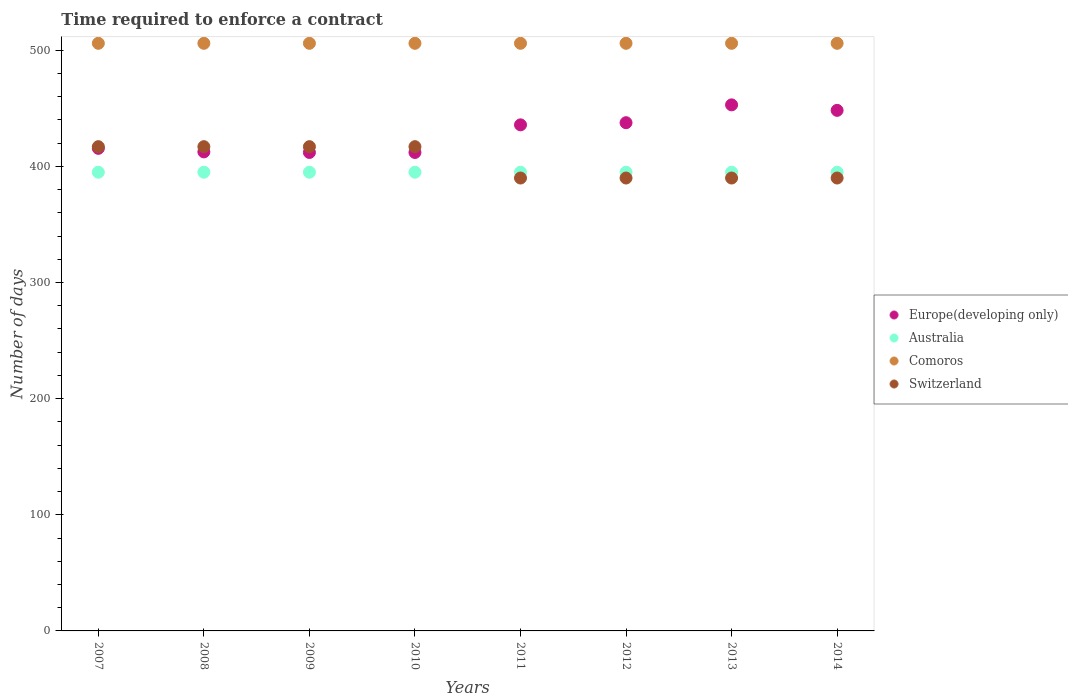How many different coloured dotlines are there?
Provide a short and direct response. 4. What is the number of days required to enforce a contract in Europe(developing only) in 2012?
Ensure brevity in your answer.  437.63. Across all years, what is the maximum number of days required to enforce a contract in Switzerland?
Ensure brevity in your answer.  417. Across all years, what is the minimum number of days required to enforce a contract in Switzerland?
Keep it short and to the point. 390. In which year was the number of days required to enforce a contract in Switzerland maximum?
Provide a succinct answer. 2007. In which year was the number of days required to enforce a contract in Australia minimum?
Offer a very short reply. 2007. What is the total number of days required to enforce a contract in Comoros in the graph?
Keep it short and to the point. 4048. What is the difference between the number of days required to enforce a contract in Australia in 2009 and that in 2011?
Offer a very short reply. 0. What is the difference between the number of days required to enforce a contract in Comoros in 2007 and the number of days required to enforce a contract in Australia in 2012?
Keep it short and to the point. 111. What is the average number of days required to enforce a contract in Europe(developing only) per year?
Keep it short and to the point. 428.34. In the year 2010, what is the difference between the number of days required to enforce a contract in Switzerland and number of days required to enforce a contract in Comoros?
Provide a succinct answer. -89. What is the ratio of the number of days required to enforce a contract in Australia in 2011 to that in 2012?
Provide a short and direct response. 1. Is the number of days required to enforce a contract in Comoros in 2008 less than that in 2010?
Make the answer very short. No. Is the difference between the number of days required to enforce a contract in Switzerland in 2009 and 2014 greater than the difference between the number of days required to enforce a contract in Comoros in 2009 and 2014?
Your answer should be compact. Yes. What is the difference between the highest and the second highest number of days required to enforce a contract in Comoros?
Your answer should be very brief. 0. What is the difference between the highest and the lowest number of days required to enforce a contract in Switzerland?
Provide a succinct answer. 27. In how many years, is the number of days required to enforce a contract in Comoros greater than the average number of days required to enforce a contract in Comoros taken over all years?
Provide a short and direct response. 0. Is the sum of the number of days required to enforce a contract in Switzerland in 2013 and 2014 greater than the maximum number of days required to enforce a contract in Australia across all years?
Offer a very short reply. Yes. Is it the case that in every year, the sum of the number of days required to enforce a contract in Europe(developing only) and number of days required to enforce a contract in Comoros  is greater than the number of days required to enforce a contract in Australia?
Ensure brevity in your answer.  Yes. How many dotlines are there?
Provide a succinct answer. 4. How many years are there in the graph?
Your answer should be compact. 8. Are the values on the major ticks of Y-axis written in scientific E-notation?
Provide a succinct answer. No. Does the graph contain any zero values?
Offer a terse response. No. Does the graph contain grids?
Ensure brevity in your answer.  No. How many legend labels are there?
Your answer should be very brief. 4. What is the title of the graph?
Your answer should be compact. Time required to enforce a contract. Does "Caribbean small states" appear as one of the legend labels in the graph?
Your answer should be compact. No. What is the label or title of the X-axis?
Provide a succinct answer. Years. What is the label or title of the Y-axis?
Your answer should be very brief. Number of days. What is the Number of days of Europe(developing only) in 2007?
Keep it short and to the point. 415.56. What is the Number of days in Australia in 2007?
Give a very brief answer. 395. What is the Number of days of Comoros in 2007?
Offer a terse response. 506. What is the Number of days in Switzerland in 2007?
Provide a short and direct response. 417. What is the Number of days in Europe(developing only) in 2008?
Your answer should be very brief. 412.5. What is the Number of days of Australia in 2008?
Provide a succinct answer. 395. What is the Number of days in Comoros in 2008?
Your answer should be compact. 506. What is the Number of days in Switzerland in 2008?
Offer a terse response. 417. What is the Number of days in Europe(developing only) in 2009?
Provide a short and direct response. 412. What is the Number of days in Australia in 2009?
Provide a short and direct response. 395. What is the Number of days of Comoros in 2009?
Your response must be concise. 506. What is the Number of days in Switzerland in 2009?
Keep it short and to the point. 417. What is the Number of days of Europe(developing only) in 2010?
Keep it short and to the point. 412. What is the Number of days in Australia in 2010?
Keep it short and to the point. 395. What is the Number of days in Comoros in 2010?
Your response must be concise. 506. What is the Number of days in Switzerland in 2010?
Your response must be concise. 417. What is the Number of days in Europe(developing only) in 2011?
Your response must be concise. 435.79. What is the Number of days in Australia in 2011?
Give a very brief answer. 395. What is the Number of days in Comoros in 2011?
Keep it short and to the point. 506. What is the Number of days of Switzerland in 2011?
Your answer should be compact. 390. What is the Number of days in Europe(developing only) in 2012?
Offer a terse response. 437.63. What is the Number of days of Australia in 2012?
Provide a succinct answer. 395. What is the Number of days of Comoros in 2012?
Make the answer very short. 506. What is the Number of days of Switzerland in 2012?
Provide a short and direct response. 390. What is the Number of days in Europe(developing only) in 2013?
Provide a short and direct response. 453. What is the Number of days in Australia in 2013?
Offer a terse response. 395. What is the Number of days of Comoros in 2013?
Provide a short and direct response. 506. What is the Number of days of Switzerland in 2013?
Your answer should be compact. 390. What is the Number of days in Europe(developing only) in 2014?
Keep it short and to the point. 448.26. What is the Number of days of Australia in 2014?
Give a very brief answer. 395. What is the Number of days in Comoros in 2014?
Ensure brevity in your answer.  506. What is the Number of days of Switzerland in 2014?
Make the answer very short. 390. Across all years, what is the maximum Number of days in Europe(developing only)?
Provide a succinct answer. 453. Across all years, what is the maximum Number of days of Australia?
Ensure brevity in your answer.  395. Across all years, what is the maximum Number of days in Comoros?
Your answer should be compact. 506. Across all years, what is the maximum Number of days of Switzerland?
Offer a very short reply. 417. Across all years, what is the minimum Number of days of Europe(developing only)?
Offer a terse response. 412. Across all years, what is the minimum Number of days of Australia?
Keep it short and to the point. 395. Across all years, what is the minimum Number of days in Comoros?
Your answer should be very brief. 506. Across all years, what is the minimum Number of days in Switzerland?
Make the answer very short. 390. What is the total Number of days in Europe(developing only) in the graph?
Your response must be concise. 3426.74. What is the total Number of days in Australia in the graph?
Your response must be concise. 3160. What is the total Number of days of Comoros in the graph?
Ensure brevity in your answer.  4048. What is the total Number of days of Switzerland in the graph?
Your answer should be compact. 3228. What is the difference between the Number of days in Europe(developing only) in 2007 and that in 2008?
Offer a very short reply. 3.06. What is the difference between the Number of days in Australia in 2007 and that in 2008?
Keep it short and to the point. 0. What is the difference between the Number of days in Comoros in 2007 and that in 2008?
Make the answer very short. 0. What is the difference between the Number of days in Switzerland in 2007 and that in 2008?
Your answer should be very brief. 0. What is the difference between the Number of days of Europe(developing only) in 2007 and that in 2009?
Keep it short and to the point. 3.56. What is the difference between the Number of days of Australia in 2007 and that in 2009?
Your answer should be compact. 0. What is the difference between the Number of days of Europe(developing only) in 2007 and that in 2010?
Your response must be concise. 3.56. What is the difference between the Number of days of Europe(developing only) in 2007 and that in 2011?
Provide a short and direct response. -20.23. What is the difference between the Number of days of Comoros in 2007 and that in 2011?
Give a very brief answer. 0. What is the difference between the Number of days of Europe(developing only) in 2007 and that in 2012?
Provide a short and direct response. -22.08. What is the difference between the Number of days in Comoros in 2007 and that in 2012?
Make the answer very short. 0. What is the difference between the Number of days of Europe(developing only) in 2007 and that in 2013?
Ensure brevity in your answer.  -37.44. What is the difference between the Number of days in Europe(developing only) in 2007 and that in 2014?
Your answer should be compact. -32.71. What is the difference between the Number of days in Comoros in 2007 and that in 2014?
Your response must be concise. 0. What is the difference between the Number of days in Switzerland in 2007 and that in 2014?
Offer a terse response. 27. What is the difference between the Number of days in Europe(developing only) in 2008 and that in 2009?
Your answer should be very brief. 0.5. What is the difference between the Number of days of Comoros in 2008 and that in 2009?
Provide a short and direct response. 0. What is the difference between the Number of days in Comoros in 2008 and that in 2010?
Give a very brief answer. 0. What is the difference between the Number of days of Switzerland in 2008 and that in 2010?
Your answer should be compact. 0. What is the difference between the Number of days of Europe(developing only) in 2008 and that in 2011?
Ensure brevity in your answer.  -23.29. What is the difference between the Number of days of Switzerland in 2008 and that in 2011?
Make the answer very short. 27. What is the difference between the Number of days in Europe(developing only) in 2008 and that in 2012?
Offer a very short reply. -25.13. What is the difference between the Number of days of Switzerland in 2008 and that in 2012?
Your answer should be very brief. 27. What is the difference between the Number of days of Europe(developing only) in 2008 and that in 2013?
Ensure brevity in your answer.  -40.5. What is the difference between the Number of days of Australia in 2008 and that in 2013?
Your answer should be compact. 0. What is the difference between the Number of days of Switzerland in 2008 and that in 2013?
Ensure brevity in your answer.  27. What is the difference between the Number of days in Europe(developing only) in 2008 and that in 2014?
Keep it short and to the point. -35.76. What is the difference between the Number of days in Australia in 2008 and that in 2014?
Give a very brief answer. 0. What is the difference between the Number of days in Comoros in 2008 and that in 2014?
Provide a succinct answer. 0. What is the difference between the Number of days in Comoros in 2009 and that in 2010?
Offer a terse response. 0. What is the difference between the Number of days of Switzerland in 2009 and that in 2010?
Your answer should be very brief. 0. What is the difference between the Number of days in Europe(developing only) in 2009 and that in 2011?
Provide a short and direct response. -23.79. What is the difference between the Number of days of Australia in 2009 and that in 2011?
Make the answer very short. 0. What is the difference between the Number of days in Comoros in 2009 and that in 2011?
Provide a short and direct response. 0. What is the difference between the Number of days of Switzerland in 2009 and that in 2011?
Offer a very short reply. 27. What is the difference between the Number of days of Europe(developing only) in 2009 and that in 2012?
Offer a very short reply. -25.63. What is the difference between the Number of days in Australia in 2009 and that in 2012?
Offer a very short reply. 0. What is the difference between the Number of days of Comoros in 2009 and that in 2012?
Give a very brief answer. 0. What is the difference between the Number of days of Switzerland in 2009 and that in 2012?
Ensure brevity in your answer.  27. What is the difference between the Number of days of Europe(developing only) in 2009 and that in 2013?
Offer a terse response. -41. What is the difference between the Number of days in Switzerland in 2009 and that in 2013?
Ensure brevity in your answer.  27. What is the difference between the Number of days in Europe(developing only) in 2009 and that in 2014?
Make the answer very short. -36.26. What is the difference between the Number of days in Comoros in 2009 and that in 2014?
Your answer should be compact. 0. What is the difference between the Number of days of Switzerland in 2009 and that in 2014?
Ensure brevity in your answer.  27. What is the difference between the Number of days of Europe(developing only) in 2010 and that in 2011?
Provide a short and direct response. -23.79. What is the difference between the Number of days in Australia in 2010 and that in 2011?
Make the answer very short. 0. What is the difference between the Number of days of Comoros in 2010 and that in 2011?
Your response must be concise. 0. What is the difference between the Number of days in Europe(developing only) in 2010 and that in 2012?
Offer a terse response. -25.63. What is the difference between the Number of days of Comoros in 2010 and that in 2012?
Offer a terse response. 0. What is the difference between the Number of days in Switzerland in 2010 and that in 2012?
Give a very brief answer. 27. What is the difference between the Number of days of Europe(developing only) in 2010 and that in 2013?
Keep it short and to the point. -41. What is the difference between the Number of days of Australia in 2010 and that in 2013?
Provide a short and direct response. 0. What is the difference between the Number of days in Switzerland in 2010 and that in 2013?
Your answer should be very brief. 27. What is the difference between the Number of days in Europe(developing only) in 2010 and that in 2014?
Make the answer very short. -36.26. What is the difference between the Number of days of Europe(developing only) in 2011 and that in 2012?
Provide a succinct answer. -1.84. What is the difference between the Number of days in Europe(developing only) in 2011 and that in 2013?
Provide a succinct answer. -17.21. What is the difference between the Number of days of Australia in 2011 and that in 2013?
Provide a short and direct response. 0. What is the difference between the Number of days in Comoros in 2011 and that in 2013?
Offer a very short reply. 0. What is the difference between the Number of days of Europe(developing only) in 2011 and that in 2014?
Your response must be concise. -12.47. What is the difference between the Number of days in Comoros in 2011 and that in 2014?
Keep it short and to the point. 0. What is the difference between the Number of days in Europe(developing only) in 2012 and that in 2013?
Give a very brief answer. -15.37. What is the difference between the Number of days in Comoros in 2012 and that in 2013?
Offer a very short reply. 0. What is the difference between the Number of days in Switzerland in 2012 and that in 2013?
Offer a terse response. 0. What is the difference between the Number of days of Europe(developing only) in 2012 and that in 2014?
Your response must be concise. -10.63. What is the difference between the Number of days in Comoros in 2012 and that in 2014?
Provide a succinct answer. 0. What is the difference between the Number of days in Europe(developing only) in 2013 and that in 2014?
Your answer should be compact. 4.74. What is the difference between the Number of days in Australia in 2013 and that in 2014?
Your answer should be very brief. 0. What is the difference between the Number of days in Europe(developing only) in 2007 and the Number of days in Australia in 2008?
Your answer should be compact. 20.56. What is the difference between the Number of days in Europe(developing only) in 2007 and the Number of days in Comoros in 2008?
Offer a very short reply. -90.44. What is the difference between the Number of days in Europe(developing only) in 2007 and the Number of days in Switzerland in 2008?
Ensure brevity in your answer.  -1.44. What is the difference between the Number of days of Australia in 2007 and the Number of days of Comoros in 2008?
Make the answer very short. -111. What is the difference between the Number of days in Australia in 2007 and the Number of days in Switzerland in 2008?
Your answer should be very brief. -22. What is the difference between the Number of days in Comoros in 2007 and the Number of days in Switzerland in 2008?
Make the answer very short. 89. What is the difference between the Number of days in Europe(developing only) in 2007 and the Number of days in Australia in 2009?
Your answer should be compact. 20.56. What is the difference between the Number of days in Europe(developing only) in 2007 and the Number of days in Comoros in 2009?
Offer a terse response. -90.44. What is the difference between the Number of days in Europe(developing only) in 2007 and the Number of days in Switzerland in 2009?
Your answer should be very brief. -1.44. What is the difference between the Number of days of Australia in 2007 and the Number of days of Comoros in 2009?
Keep it short and to the point. -111. What is the difference between the Number of days in Comoros in 2007 and the Number of days in Switzerland in 2009?
Ensure brevity in your answer.  89. What is the difference between the Number of days in Europe(developing only) in 2007 and the Number of days in Australia in 2010?
Provide a short and direct response. 20.56. What is the difference between the Number of days in Europe(developing only) in 2007 and the Number of days in Comoros in 2010?
Provide a succinct answer. -90.44. What is the difference between the Number of days in Europe(developing only) in 2007 and the Number of days in Switzerland in 2010?
Provide a succinct answer. -1.44. What is the difference between the Number of days of Australia in 2007 and the Number of days of Comoros in 2010?
Provide a short and direct response. -111. What is the difference between the Number of days of Australia in 2007 and the Number of days of Switzerland in 2010?
Ensure brevity in your answer.  -22. What is the difference between the Number of days of Comoros in 2007 and the Number of days of Switzerland in 2010?
Your answer should be compact. 89. What is the difference between the Number of days in Europe(developing only) in 2007 and the Number of days in Australia in 2011?
Provide a short and direct response. 20.56. What is the difference between the Number of days in Europe(developing only) in 2007 and the Number of days in Comoros in 2011?
Your answer should be very brief. -90.44. What is the difference between the Number of days in Europe(developing only) in 2007 and the Number of days in Switzerland in 2011?
Ensure brevity in your answer.  25.56. What is the difference between the Number of days in Australia in 2007 and the Number of days in Comoros in 2011?
Provide a short and direct response. -111. What is the difference between the Number of days of Australia in 2007 and the Number of days of Switzerland in 2011?
Your answer should be compact. 5. What is the difference between the Number of days of Comoros in 2007 and the Number of days of Switzerland in 2011?
Keep it short and to the point. 116. What is the difference between the Number of days of Europe(developing only) in 2007 and the Number of days of Australia in 2012?
Provide a succinct answer. 20.56. What is the difference between the Number of days in Europe(developing only) in 2007 and the Number of days in Comoros in 2012?
Your answer should be compact. -90.44. What is the difference between the Number of days in Europe(developing only) in 2007 and the Number of days in Switzerland in 2012?
Offer a very short reply. 25.56. What is the difference between the Number of days in Australia in 2007 and the Number of days in Comoros in 2012?
Your answer should be very brief. -111. What is the difference between the Number of days in Australia in 2007 and the Number of days in Switzerland in 2012?
Keep it short and to the point. 5. What is the difference between the Number of days in Comoros in 2007 and the Number of days in Switzerland in 2012?
Ensure brevity in your answer.  116. What is the difference between the Number of days in Europe(developing only) in 2007 and the Number of days in Australia in 2013?
Your response must be concise. 20.56. What is the difference between the Number of days in Europe(developing only) in 2007 and the Number of days in Comoros in 2013?
Make the answer very short. -90.44. What is the difference between the Number of days of Europe(developing only) in 2007 and the Number of days of Switzerland in 2013?
Provide a succinct answer. 25.56. What is the difference between the Number of days in Australia in 2007 and the Number of days in Comoros in 2013?
Ensure brevity in your answer.  -111. What is the difference between the Number of days of Comoros in 2007 and the Number of days of Switzerland in 2013?
Offer a very short reply. 116. What is the difference between the Number of days in Europe(developing only) in 2007 and the Number of days in Australia in 2014?
Give a very brief answer. 20.56. What is the difference between the Number of days of Europe(developing only) in 2007 and the Number of days of Comoros in 2014?
Provide a short and direct response. -90.44. What is the difference between the Number of days in Europe(developing only) in 2007 and the Number of days in Switzerland in 2014?
Make the answer very short. 25.56. What is the difference between the Number of days of Australia in 2007 and the Number of days of Comoros in 2014?
Give a very brief answer. -111. What is the difference between the Number of days in Comoros in 2007 and the Number of days in Switzerland in 2014?
Make the answer very short. 116. What is the difference between the Number of days of Europe(developing only) in 2008 and the Number of days of Comoros in 2009?
Your answer should be compact. -93.5. What is the difference between the Number of days in Australia in 2008 and the Number of days in Comoros in 2009?
Offer a terse response. -111. What is the difference between the Number of days in Australia in 2008 and the Number of days in Switzerland in 2009?
Give a very brief answer. -22. What is the difference between the Number of days of Comoros in 2008 and the Number of days of Switzerland in 2009?
Keep it short and to the point. 89. What is the difference between the Number of days in Europe(developing only) in 2008 and the Number of days in Comoros in 2010?
Provide a short and direct response. -93.5. What is the difference between the Number of days in Europe(developing only) in 2008 and the Number of days in Switzerland in 2010?
Ensure brevity in your answer.  -4.5. What is the difference between the Number of days in Australia in 2008 and the Number of days in Comoros in 2010?
Provide a short and direct response. -111. What is the difference between the Number of days in Comoros in 2008 and the Number of days in Switzerland in 2010?
Your answer should be very brief. 89. What is the difference between the Number of days in Europe(developing only) in 2008 and the Number of days in Comoros in 2011?
Ensure brevity in your answer.  -93.5. What is the difference between the Number of days of Australia in 2008 and the Number of days of Comoros in 2011?
Offer a terse response. -111. What is the difference between the Number of days in Comoros in 2008 and the Number of days in Switzerland in 2011?
Offer a very short reply. 116. What is the difference between the Number of days of Europe(developing only) in 2008 and the Number of days of Australia in 2012?
Give a very brief answer. 17.5. What is the difference between the Number of days in Europe(developing only) in 2008 and the Number of days in Comoros in 2012?
Ensure brevity in your answer.  -93.5. What is the difference between the Number of days in Europe(developing only) in 2008 and the Number of days in Switzerland in 2012?
Offer a terse response. 22.5. What is the difference between the Number of days in Australia in 2008 and the Number of days in Comoros in 2012?
Give a very brief answer. -111. What is the difference between the Number of days of Comoros in 2008 and the Number of days of Switzerland in 2012?
Your answer should be compact. 116. What is the difference between the Number of days in Europe(developing only) in 2008 and the Number of days in Comoros in 2013?
Provide a short and direct response. -93.5. What is the difference between the Number of days of Australia in 2008 and the Number of days of Comoros in 2013?
Your answer should be very brief. -111. What is the difference between the Number of days of Comoros in 2008 and the Number of days of Switzerland in 2013?
Provide a short and direct response. 116. What is the difference between the Number of days of Europe(developing only) in 2008 and the Number of days of Comoros in 2014?
Your response must be concise. -93.5. What is the difference between the Number of days of Europe(developing only) in 2008 and the Number of days of Switzerland in 2014?
Your answer should be compact. 22.5. What is the difference between the Number of days of Australia in 2008 and the Number of days of Comoros in 2014?
Keep it short and to the point. -111. What is the difference between the Number of days of Australia in 2008 and the Number of days of Switzerland in 2014?
Your answer should be compact. 5. What is the difference between the Number of days of Comoros in 2008 and the Number of days of Switzerland in 2014?
Your answer should be very brief. 116. What is the difference between the Number of days of Europe(developing only) in 2009 and the Number of days of Comoros in 2010?
Give a very brief answer. -94. What is the difference between the Number of days in Australia in 2009 and the Number of days in Comoros in 2010?
Your answer should be very brief. -111. What is the difference between the Number of days of Australia in 2009 and the Number of days of Switzerland in 2010?
Keep it short and to the point. -22. What is the difference between the Number of days in Comoros in 2009 and the Number of days in Switzerland in 2010?
Make the answer very short. 89. What is the difference between the Number of days of Europe(developing only) in 2009 and the Number of days of Comoros in 2011?
Your answer should be very brief. -94. What is the difference between the Number of days of Australia in 2009 and the Number of days of Comoros in 2011?
Provide a succinct answer. -111. What is the difference between the Number of days of Australia in 2009 and the Number of days of Switzerland in 2011?
Keep it short and to the point. 5. What is the difference between the Number of days in Comoros in 2009 and the Number of days in Switzerland in 2011?
Give a very brief answer. 116. What is the difference between the Number of days of Europe(developing only) in 2009 and the Number of days of Australia in 2012?
Offer a terse response. 17. What is the difference between the Number of days of Europe(developing only) in 2009 and the Number of days of Comoros in 2012?
Make the answer very short. -94. What is the difference between the Number of days in Australia in 2009 and the Number of days in Comoros in 2012?
Your answer should be compact. -111. What is the difference between the Number of days in Australia in 2009 and the Number of days in Switzerland in 2012?
Your response must be concise. 5. What is the difference between the Number of days in Comoros in 2009 and the Number of days in Switzerland in 2012?
Make the answer very short. 116. What is the difference between the Number of days in Europe(developing only) in 2009 and the Number of days in Comoros in 2013?
Offer a very short reply. -94. What is the difference between the Number of days of Europe(developing only) in 2009 and the Number of days of Switzerland in 2013?
Provide a short and direct response. 22. What is the difference between the Number of days of Australia in 2009 and the Number of days of Comoros in 2013?
Provide a succinct answer. -111. What is the difference between the Number of days of Australia in 2009 and the Number of days of Switzerland in 2013?
Provide a short and direct response. 5. What is the difference between the Number of days of Comoros in 2009 and the Number of days of Switzerland in 2013?
Keep it short and to the point. 116. What is the difference between the Number of days of Europe(developing only) in 2009 and the Number of days of Comoros in 2014?
Provide a short and direct response. -94. What is the difference between the Number of days in Australia in 2009 and the Number of days in Comoros in 2014?
Offer a very short reply. -111. What is the difference between the Number of days of Australia in 2009 and the Number of days of Switzerland in 2014?
Provide a succinct answer. 5. What is the difference between the Number of days of Comoros in 2009 and the Number of days of Switzerland in 2014?
Your response must be concise. 116. What is the difference between the Number of days in Europe(developing only) in 2010 and the Number of days in Australia in 2011?
Provide a succinct answer. 17. What is the difference between the Number of days of Europe(developing only) in 2010 and the Number of days of Comoros in 2011?
Give a very brief answer. -94. What is the difference between the Number of days in Europe(developing only) in 2010 and the Number of days in Switzerland in 2011?
Make the answer very short. 22. What is the difference between the Number of days of Australia in 2010 and the Number of days of Comoros in 2011?
Provide a short and direct response. -111. What is the difference between the Number of days of Comoros in 2010 and the Number of days of Switzerland in 2011?
Make the answer very short. 116. What is the difference between the Number of days in Europe(developing only) in 2010 and the Number of days in Comoros in 2012?
Provide a succinct answer. -94. What is the difference between the Number of days in Europe(developing only) in 2010 and the Number of days in Switzerland in 2012?
Give a very brief answer. 22. What is the difference between the Number of days in Australia in 2010 and the Number of days in Comoros in 2012?
Offer a terse response. -111. What is the difference between the Number of days in Australia in 2010 and the Number of days in Switzerland in 2012?
Your answer should be compact. 5. What is the difference between the Number of days of Comoros in 2010 and the Number of days of Switzerland in 2012?
Your response must be concise. 116. What is the difference between the Number of days in Europe(developing only) in 2010 and the Number of days in Australia in 2013?
Provide a short and direct response. 17. What is the difference between the Number of days in Europe(developing only) in 2010 and the Number of days in Comoros in 2013?
Your response must be concise. -94. What is the difference between the Number of days of Europe(developing only) in 2010 and the Number of days of Switzerland in 2013?
Make the answer very short. 22. What is the difference between the Number of days in Australia in 2010 and the Number of days in Comoros in 2013?
Make the answer very short. -111. What is the difference between the Number of days of Australia in 2010 and the Number of days of Switzerland in 2013?
Offer a terse response. 5. What is the difference between the Number of days of Comoros in 2010 and the Number of days of Switzerland in 2013?
Keep it short and to the point. 116. What is the difference between the Number of days in Europe(developing only) in 2010 and the Number of days in Australia in 2014?
Your response must be concise. 17. What is the difference between the Number of days of Europe(developing only) in 2010 and the Number of days of Comoros in 2014?
Keep it short and to the point. -94. What is the difference between the Number of days in Australia in 2010 and the Number of days in Comoros in 2014?
Offer a very short reply. -111. What is the difference between the Number of days in Comoros in 2010 and the Number of days in Switzerland in 2014?
Ensure brevity in your answer.  116. What is the difference between the Number of days of Europe(developing only) in 2011 and the Number of days of Australia in 2012?
Provide a succinct answer. 40.79. What is the difference between the Number of days in Europe(developing only) in 2011 and the Number of days in Comoros in 2012?
Ensure brevity in your answer.  -70.21. What is the difference between the Number of days of Europe(developing only) in 2011 and the Number of days of Switzerland in 2012?
Give a very brief answer. 45.79. What is the difference between the Number of days in Australia in 2011 and the Number of days in Comoros in 2012?
Ensure brevity in your answer.  -111. What is the difference between the Number of days in Comoros in 2011 and the Number of days in Switzerland in 2012?
Give a very brief answer. 116. What is the difference between the Number of days in Europe(developing only) in 2011 and the Number of days in Australia in 2013?
Provide a short and direct response. 40.79. What is the difference between the Number of days in Europe(developing only) in 2011 and the Number of days in Comoros in 2013?
Offer a very short reply. -70.21. What is the difference between the Number of days of Europe(developing only) in 2011 and the Number of days of Switzerland in 2013?
Offer a terse response. 45.79. What is the difference between the Number of days of Australia in 2011 and the Number of days of Comoros in 2013?
Your answer should be compact. -111. What is the difference between the Number of days of Australia in 2011 and the Number of days of Switzerland in 2013?
Offer a very short reply. 5. What is the difference between the Number of days in Comoros in 2011 and the Number of days in Switzerland in 2013?
Your answer should be very brief. 116. What is the difference between the Number of days in Europe(developing only) in 2011 and the Number of days in Australia in 2014?
Offer a terse response. 40.79. What is the difference between the Number of days in Europe(developing only) in 2011 and the Number of days in Comoros in 2014?
Your answer should be very brief. -70.21. What is the difference between the Number of days in Europe(developing only) in 2011 and the Number of days in Switzerland in 2014?
Provide a succinct answer. 45.79. What is the difference between the Number of days of Australia in 2011 and the Number of days of Comoros in 2014?
Your response must be concise. -111. What is the difference between the Number of days in Australia in 2011 and the Number of days in Switzerland in 2014?
Offer a terse response. 5. What is the difference between the Number of days in Comoros in 2011 and the Number of days in Switzerland in 2014?
Your answer should be very brief. 116. What is the difference between the Number of days of Europe(developing only) in 2012 and the Number of days of Australia in 2013?
Provide a succinct answer. 42.63. What is the difference between the Number of days of Europe(developing only) in 2012 and the Number of days of Comoros in 2013?
Provide a short and direct response. -68.37. What is the difference between the Number of days in Europe(developing only) in 2012 and the Number of days in Switzerland in 2013?
Offer a terse response. 47.63. What is the difference between the Number of days in Australia in 2012 and the Number of days in Comoros in 2013?
Your answer should be compact. -111. What is the difference between the Number of days of Comoros in 2012 and the Number of days of Switzerland in 2013?
Your answer should be very brief. 116. What is the difference between the Number of days in Europe(developing only) in 2012 and the Number of days in Australia in 2014?
Make the answer very short. 42.63. What is the difference between the Number of days of Europe(developing only) in 2012 and the Number of days of Comoros in 2014?
Offer a terse response. -68.37. What is the difference between the Number of days in Europe(developing only) in 2012 and the Number of days in Switzerland in 2014?
Ensure brevity in your answer.  47.63. What is the difference between the Number of days in Australia in 2012 and the Number of days in Comoros in 2014?
Give a very brief answer. -111. What is the difference between the Number of days in Australia in 2012 and the Number of days in Switzerland in 2014?
Offer a terse response. 5. What is the difference between the Number of days in Comoros in 2012 and the Number of days in Switzerland in 2014?
Ensure brevity in your answer.  116. What is the difference between the Number of days in Europe(developing only) in 2013 and the Number of days in Comoros in 2014?
Your answer should be compact. -53. What is the difference between the Number of days in Europe(developing only) in 2013 and the Number of days in Switzerland in 2014?
Make the answer very short. 63. What is the difference between the Number of days of Australia in 2013 and the Number of days of Comoros in 2014?
Your answer should be compact. -111. What is the difference between the Number of days in Australia in 2013 and the Number of days in Switzerland in 2014?
Your answer should be compact. 5. What is the difference between the Number of days in Comoros in 2013 and the Number of days in Switzerland in 2014?
Give a very brief answer. 116. What is the average Number of days in Europe(developing only) per year?
Provide a short and direct response. 428.34. What is the average Number of days of Australia per year?
Make the answer very short. 395. What is the average Number of days of Comoros per year?
Keep it short and to the point. 506. What is the average Number of days of Switzerland per year?
Your response must be concise. 403.5. In the year 2007, what is the difference between the Number of days of Europe(developing only) and Number of days of Australia?
Provide a succinct answer. 20.56. In the year 2007, what is the difference between the Number of days of Europe(developing only) and Number of days of Comoros?
Offer a very short reply. -90.44. In the year 2007, what is the difference between the Number of days in Europe(developing only) and Number of days in Switzerland?
Your answer should be very brief. -1.44. In the year 2007, what is the difference between the Number of days of Australia and Number of days of Comoros?
Your answer should be very brief. -111. In the year 2007, what is the difference between the Number of days in Comoros and Number of days in Switzerland?
Keep it short and to the point. 89. In the year 2008, what is the difference between the Number of days in Europe(developing only) and Number of days in Australia?
Make the answer very short. 17.5. In the year 2008, what is the difference between the Number of days of Europe(developing only) and Number of days of Comoros?
Provide a short and direct response. -93.5. In the year 2008, what is the difference between the Number of days of Australia and Number of days of Comoros?
Provide a short and direct response. -111. In the year 2008, what is the difference between the Number of days in Comoros and Number of days in Switzerland?
Your response must be concise. 89. In the year 2009, what is the difference between the Number of days of Europe(developing only) and Number of days of Australia?
Ensure brevity in your answer.  17. In the year 2009, what is the difference between the Number of days of Europe(developing only) and Number of days of Comoros?
Your answer should be compact. -94. In the year 2009, what is the difference between the Number of days of Europe(developing only) and Number of days of Switzerland?
Provide a succinct answer. -5. In the year 2009, what is the difference between the Number of days of Australia and Number of days of Comoros?
Provide a succinct answer. -111. In the year 2009, what is the difference between the Number of days of Australia and Number of days of Switzerland?
Make the answer very short. -22. In the year 2009, what is the difference between the Number of days in Comoros and Number of days in Switzerland?
Offer a terse response. 89. In the year 2010, what is the difference between the Number of days of Europe(developing only) and Number of days of Comoros?
Make the answer very short. -94. In the year 2010, what is the difference between the Number of days in Australia and Number of days in Comoros?
Offer a terse response. -111. In the year 2010, what is the difference between the Number of days of Comoros and Number of days of Switzerland?
Your answer should be compact. 89. In the year 2011, what is the difference between the Number of days of Europe(developing only) and Number of days of Australia?
Make the answer very short. 40.79. In the year 2011, what is the difference between the Number of days in Europe(developing only) and Number of days in Comoros?
Keep it short and to the point. -70.21. In the year 2011, what is the difference between the Number of days of Europe(developing only) and Number of days of Switzerland?
Keep it short and to the point. 45.79. In the year 2011, what is the difference between the Number of days of Australia and Number of days of Comoros?
Keep it short and to the point. -111. In the year 2011, what is the difference between the Number of days of Australia and Number of days of Switzerland?
Make the answer very short. 5. In the year 2011, what is the difference between the Number of days in Comoros and Number of days in Switzerland?
Offer a terse response. 116. In the year 2012, what is the difference between the Number of days in Europe(developing only) and Number of days in Australia?
Make the answer very short. 42.63. In the year 2012, what is the difference between the Number of days in Europe(developing only) and Number of days in Comoros?
Provide a succinct answer. -68.37. In the year 2012, what is the difference between the Number of days of Europe(developing only) and Number of days of Switzerland?
Keep it short and to the point. 47.63. In the year 2012, what is the difference between the Number of days of Australia and Number of days of Comoros?
Give a very brief answer. -111. In the year 2012, what is the difference between the Number of days in Comoros and Number of days in Switzerland?
Your answer should be compact. 116. In the year 2013, what is the difference between the Number of days in Europe(developing only) and Number of days in Comoros?
Make the answer very short. -53. In the year 2013, what is the difference between the Number of days in Europe(developing only) and Number of days in Switzerland?
Provide a succinct answer. 63. In the year 2013, what is the difference between the Number of days in Australia and Number of days in Comoros?
Make the answer very short. -111. In the year 2013, what is the difference between the Number of days of Comoros and Number of days of Switzerland?
Give a very brief answer. 116. In the year 2014, what is the difference between the Number of days of Europe(developing only) and Number of days of Australia?
Your response must be concise. 53.26. In the year 2014, what is the difference between the Number of days of Europe(developing only) and Number of days of Comoros?
Make the answer very short. -57.74. In the year 2014, what is the difference between the Number of days in Europe(developing only) and Number of days in Switzerland?
Provide a short and direct response. 58.26. In the year 2014, what is the difference between the Number of days in Australia and Number of days in Comoros?
Your response must be concise. -111. In the year 2014, what is the difference between the Number of days of Comoros and Number of days of Switzerland?
Ensure brevity in your answer.  116. What is the ratio of the Number of days of Europe(developing only) in 2007 to that in 2008?
Offer a very short reply. 1.01. What is the ratio of the Number of days in Comoros in 2007 to that in 2008?
Offer a very short reply. 1. What is the ratio of the Number of days in Europe(developing only) in 2007 to that in 2009?
Give a very brief answer. 1.01. What is the ratio of the Number of days in Australia in 2007 to that in 2009?
Make the answer very short. 1. What is the ratio of the Number of days of Europe(developing only) in 2007 to that in 2010?
Offer a very short reply. 1.01. What is the ratio of the Number of days of Australia in 2007 to that in 2010?
Make the answer very short. 1. What is the ratio of the Number of days of Switzerland in 2007 to that in 2010?
Ensure brevity in your answer.  1. What is the ratio of the Number of days of Europe(developing only) in 2007 to that in 2011?
Your response must be concise. 0.95. What is the ratio of the Number of days of Australia in 2007 to that in 2011?
Offer a terse response. 1. What is the ratio of the Number of days of Switzerland in 2007 to that in 2011?
Ensure brevity in your answer.  1.07. What is the ratio of the Number of days in Europe(developing only) in 2007 to that in 2012?
Your answer should be compact. 0.95. What is the ratio of the Number of days of Switzerland in 2007 to that in 2012?
Keep it short and to the point. 1.07. What is the ratio of the Number of days in Europe(developing only) in 2007 to that in 2013?
Give a very brief answer. 0.92. What is the ratio of the Number of days in Switzerland in 2007 to that in 2013?
Give a very brief answer. 1.07. What is the ratio of the Number of days of Europe(developing only) in 2007 to that in 2014?
Provide a short and direct response. 0.93. What is the ratio of the Number of days of Australia in 2007 to that in 2014?
Offer a very short reply. 1. What is the ratio of the Number of days in Switzerland in 2007 to that in 2014?
Your answer should be very brief. 1.07. What is the ratio of the Number of days in Europe(developing only) in 2008 to that in 2009?
Provide a short and direct response. 1. What is the ratio of the Number of days in Australia in 2008 to that in 2009?
Offer a very short reply. 1. What is the ratio of the Number of days of Australia in 2008 to that in 2010?
Offer a terse response. 1. What is the ratio of the Number of days of Europe(developing only) in 2008 to that in 2011?
Provide a succinct answer. 0.95. What is the ratio of the Number of days in Comoros in 2008 to that in 2011?
Provide a succinct answer. 1. What is the ratio of the Number of days in Switzerland in 2008 to that in 2011?
Your response must be concise. 1.07. What is the ratio of the Number of days in Europe(developing only) in 2008 to that in 2012?
Your response must be concise. 0.94. What is the ratio of the Number of days of Australia in 2008 to that in 2012?
Your response must be concise. 1. What is the ratio of the Number of days of Switzerland in 2008 to that in 2012?
Provide a short and direct response. 1.07. What is the ratio of the Number of days in Europe(developing only) in 2008 to that in 2013?
Ensure brevity in your answer.  0.91. What is the ratio of the Number of days of Switzerland in 2008 to that in 2013?
Your answer should be very brief. 1.07. What is the ratio of the Number of days of Europe(developing only) in 2008 to that in 2014?
Ensure brevity in your answer.  0.92. What is the ratio of the Number of days in Switzerland in 2008 to that in 2014?
Offer a terse response. 1.07. What is the ratio of the Number of days in Europe(developing only) in 2009 to that in 2010?
Your answer should be compact. 1. What is the ratio of the Number of days in Comoros in 2009 to that in 2010?
Your response must be concise. 1. What is the ratio of the Number of days of Europe(developing only) in 2009 to that in 2011?
Your answer should be compact. 0.95. What is the ratio of the Number of days in Comoros in 2009 to that in 2011?
Ensure brevity in your answer.  1. What is the ratio of the Number of days in Switzerland in 2009 to that in 2011?
Ensure brevity in your answer.  1.07. What is the ratio of the Number of days of Europe(developing only) in 2009 to that in 2012?
Provide a short and direct response. 0.94. What is the ratio of the Number of days of Comoros in 2009 to that in 2012?
Your answer should be very brief. 1. What is the ratio of the Number of days of Switzerland in 2009 to that in 2012?
Offer a terse response. 1.07. What is the ratio of the Number of days in Europe(developing only) in 2009 to that in 2013?
Make the answer very short. 0.91. What is the ratio of the Number of days of Switzerland in 2009 to that in 2013?
Your answer should be compact. 1.07. What is the ratio of the Number of days of Europe(developing only) in 2009 to that in 2014?
Provide a succinct answer. 0.92. What is the ratio of the Number of days of Australia in 2009 to that in 2014?
Give a very brief answer. 1. What is the ratio of the Number of days in Comoros in 2009 to that in 2014?
Make the answer very short. 1. What is the ratio of the Number of days of Switzerland in 2009 to that in 2014?
Provide a succinct answer. 1.07. What is the ratio of the Number of days in Europe(developing only) in 2010 to that in 2011?
Make the answer very short. 0.95. What is the ratio of the Number of days of Australia in 2010 to that in 2011?
Provide a succinct answer. 1. What is the ratio of the Number of days in Comoros in 2010 to that in 2011?
Keep it short and to the point. 1. What is the ratio of the Number of days of Switzerland in 2010 to that in 2011?
Your answer should be compact. 1.07. What is the ratio of the Number of days in Europe(developing only) in 2010 to that in 2012?
Keep it short and to the point. 0.94. What is the ratio of the Number of days in Switzerland in 2010 to that in 2012?
Offer a terse response. 1.07. What is the ratio of the Number of days in Europe(developing only) in 2010 to that in 2013?
Offer a very short reply. 0.91. What is the ratio of the Number of days of Australia in 2010 to that in 2013?
Your answer should be compact. 1. What is the ratio of the Number of days of Switzerland in 2010 to that in 2013?
Provide a succinct answer. 1.07. What is the ratio of the Number of days of Europe(developing only) in 2010 to that in 2014?
Your response must be concise. 0.92. What is the ratio of the Number of days of Switzerland in 2010 to that in 2014?
Keep it short and to the point. 1.07. What is the ratio of the Number of days of Europe(developing only) in 2011 to that in 2014?
Provide a short and direct response. 0.97. What is the ratio of the Number of days in Australia in 2011 to that in 2014?
Provide a short and direct response. 1. What is the ratio of the Number of days of Europe(developing only) in 2012 to that in 2013?
Your response must be concise. 0.97. What is the ratio of the Number of days in Australia in 2012 to that in 2013?
Keep it short and to the point. 1. What is the ratio of the Number of days in Europe(developing only) in 2012 to that in 2014?
Provide a succinct answer. 0.98. What is the ratio of the Number of days in Australia in 2012 to that in 2014?
Keep it short and to the point. 1. What is the ratio of the Number of days in Comoros in 2012 to that in 2014?
Ensure brevity in your answer.  1. What is the ratio of the Number of days of Europe(developing only) in 2013 to that in 2014?
Your answer should be compact. 1.01. What is the ratio of the Number of days in Australia in 2013 to that in 2014?
Your response must be concise. 1. What is the ratio of the Number of days in Switzerland in 2013 to that in 2014?
Your response must be concise. 1. What is the difference between the highest and the second highest Number of days in Europe(developing only)?
Offer a very short reply. 4.74. What is the difference between the highest and the second highest Number of days of Australia?
Offer a terse response. 0. What is the difference between the highest and the second highest Number of days of Comoros?
Offer a very short reply. 0. What is the difference between the highest and the lowest Number of days in Europe(developing only)?
Provide a short and direct response. 41. 